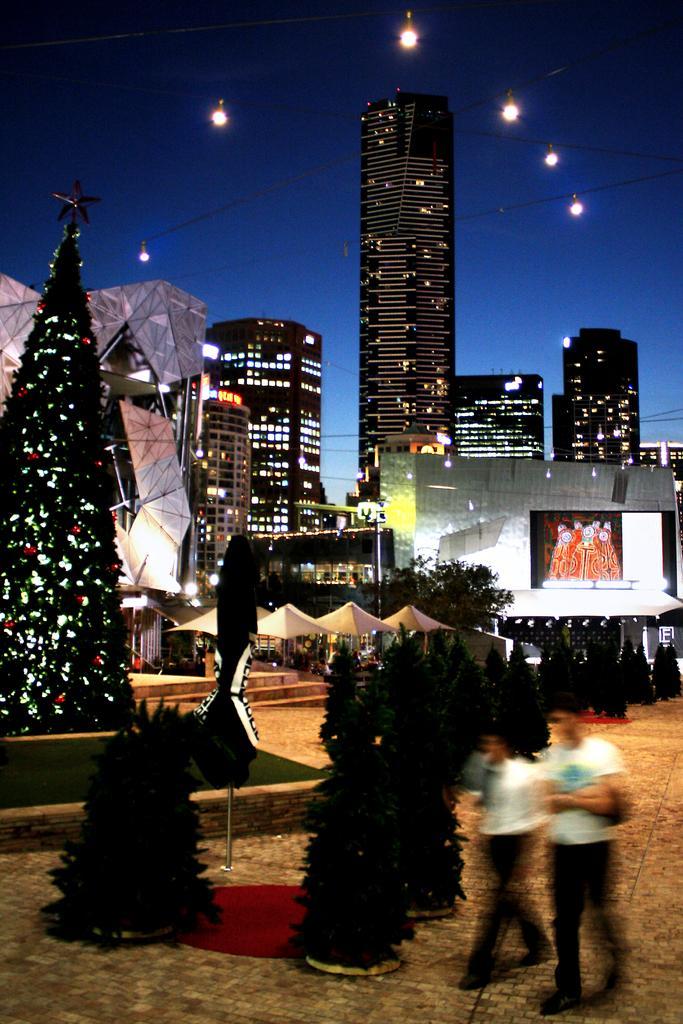Could you give a brief overview of what you see in this image? In this image there are two people walking on a pavement, in the background there Christmas trees, buildings, lights and the sky. 